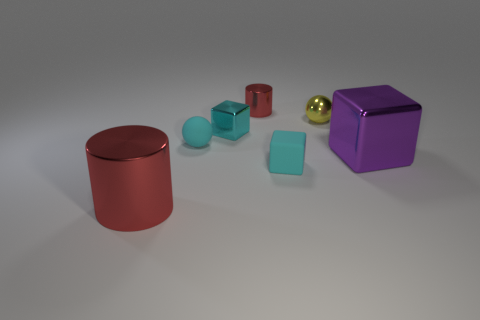Add 1 purple things. How many objects exist? 8 Subtract all cylinders. How many objects are left? 5 Subtract all tiny brown matte blocks. Subtract all small spheres. How many objects are left? 5 Add 6 tiny cylinders. How many tiny cylinders are left? 7 Add 3 small red cylinders. How many small red cylinders exist? 4 Subtract 0 red balls. How many objects are left? 7 